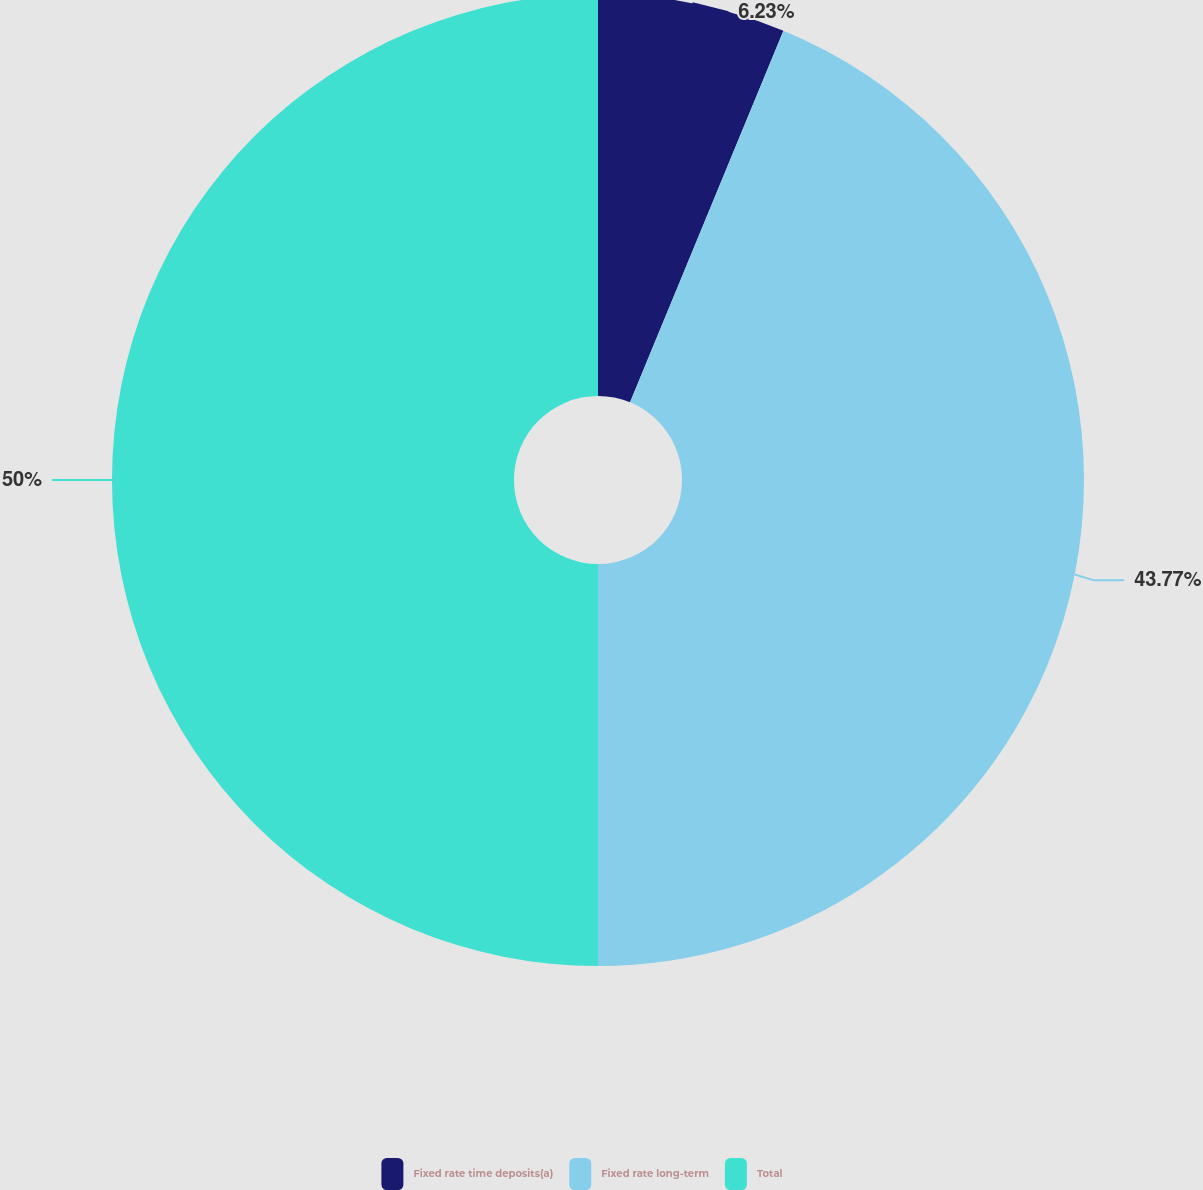Convert chart to OTSL. <chart><loc_0><loc_0><loc_500><loc_500><pie_chart><fcel>Fixed rate time deposits(a)<fcel>Fixed rate long-term<fcel>Total<nl><fcel>6.23%<fcel>43.77%<fcel>50.0%<nl></chart> 